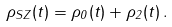Convert formula to latex. <formula><loc_0><loc_0><loc_500><loc_500>\rho _ { S Z } ( t ) = \rho _ { 0 } ( t ) + \rho _ { 2 } ( t ) \, .</formula> 